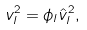Convert formula to latex. <formula><loc_0><loc_0><loc_500><loc_500>v _ { l } ^ { 2 } = \phi _ { l } \hat { v } _ { l } ^ { 2 } ,</formula> 